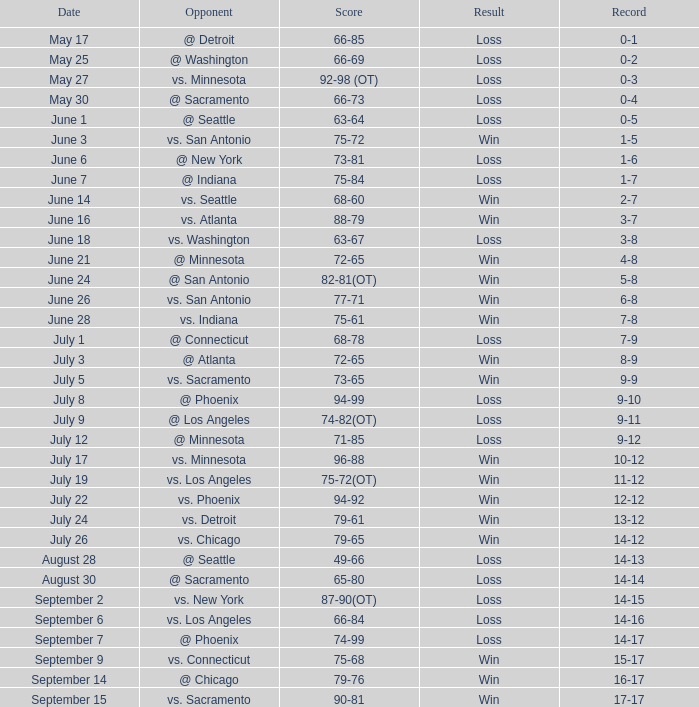What was the consequence on july 24? Win. 